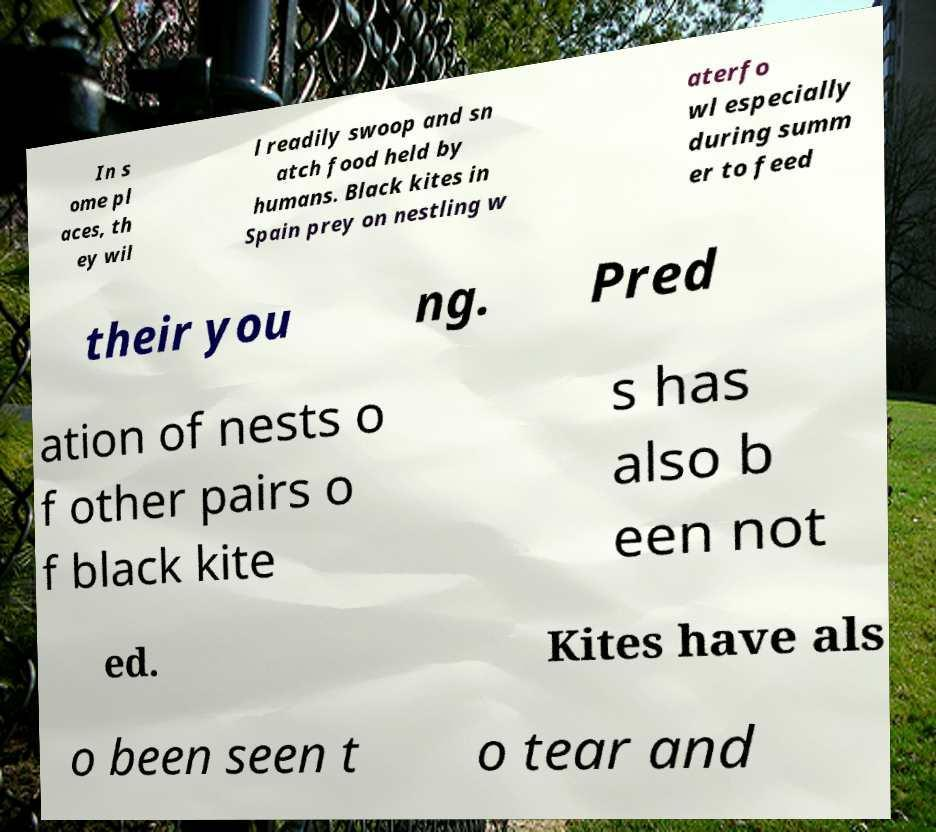What messages or text are displayed in this image? I need them in a readable, typed format. In s ome pl aces, th ey wil l readily swoop and sn atch food held by humans. Black kites in Spain prey on nestling w aterfo wl especially during summ er to feed their you ng. Pred ation of nests o f other pairs o f black kite s has also b een not ed. Kites have als o been seen t o tear and 